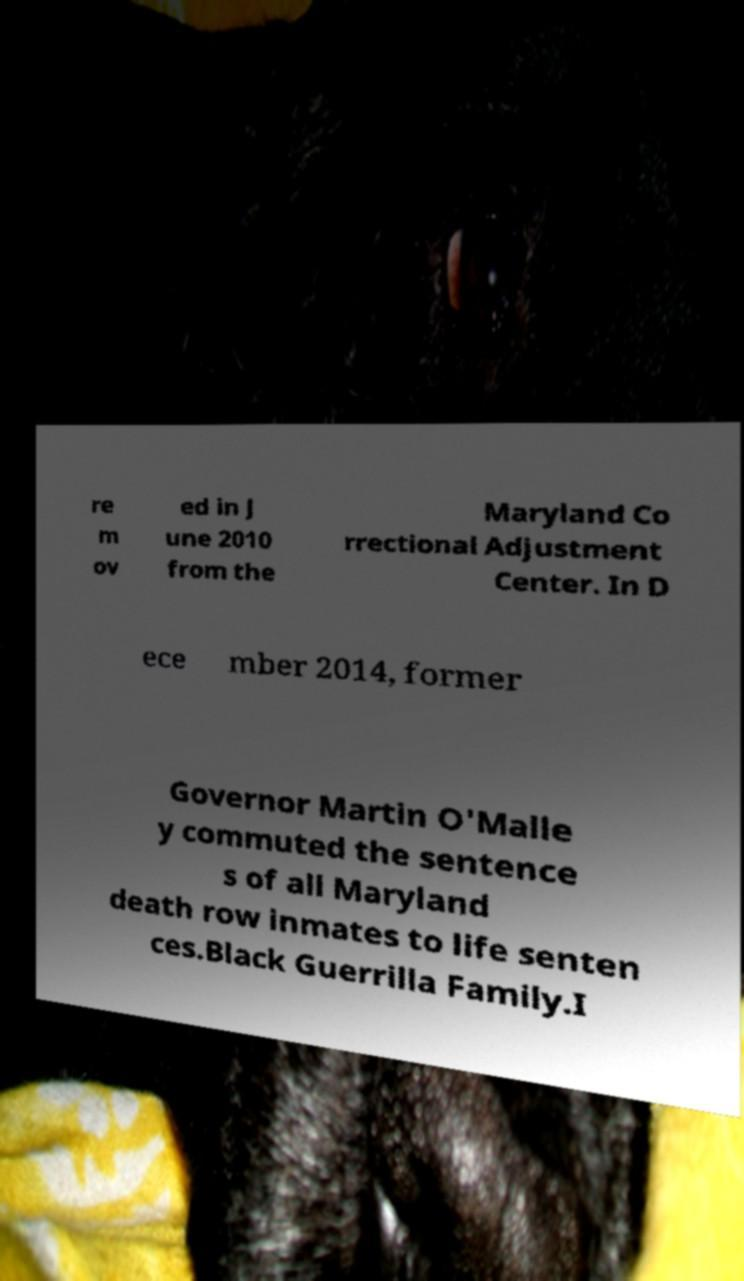I need the written content from this picture converted into text. Can you do that? re m ov ed in J une 2010 from the Maryland Co rrectional Adjustment Center. In D ece mber 2014, former Governor Martin O'Malle y commuted the sentence s of all Maryland death row inmates to life senten ces.Black Guerrilla Family.I 